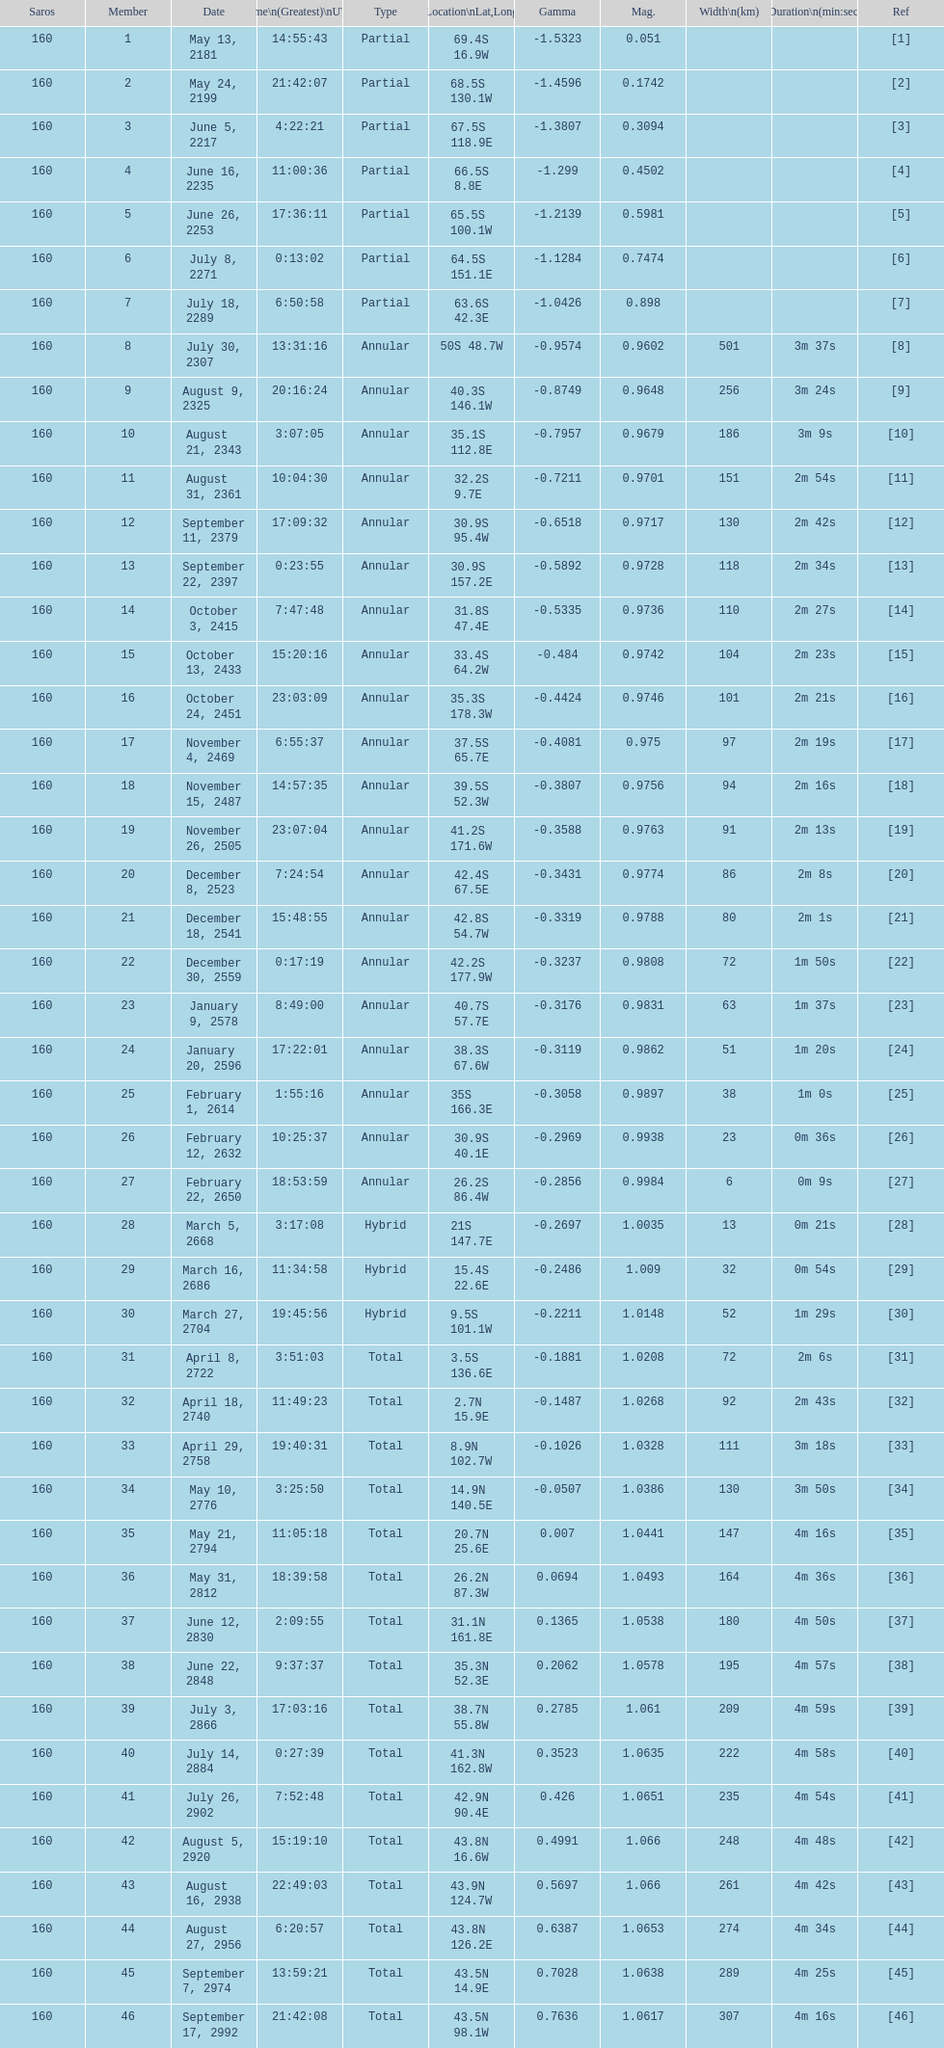How many solar saros occurrences had a duration exceeding 4 minutes? 12. 